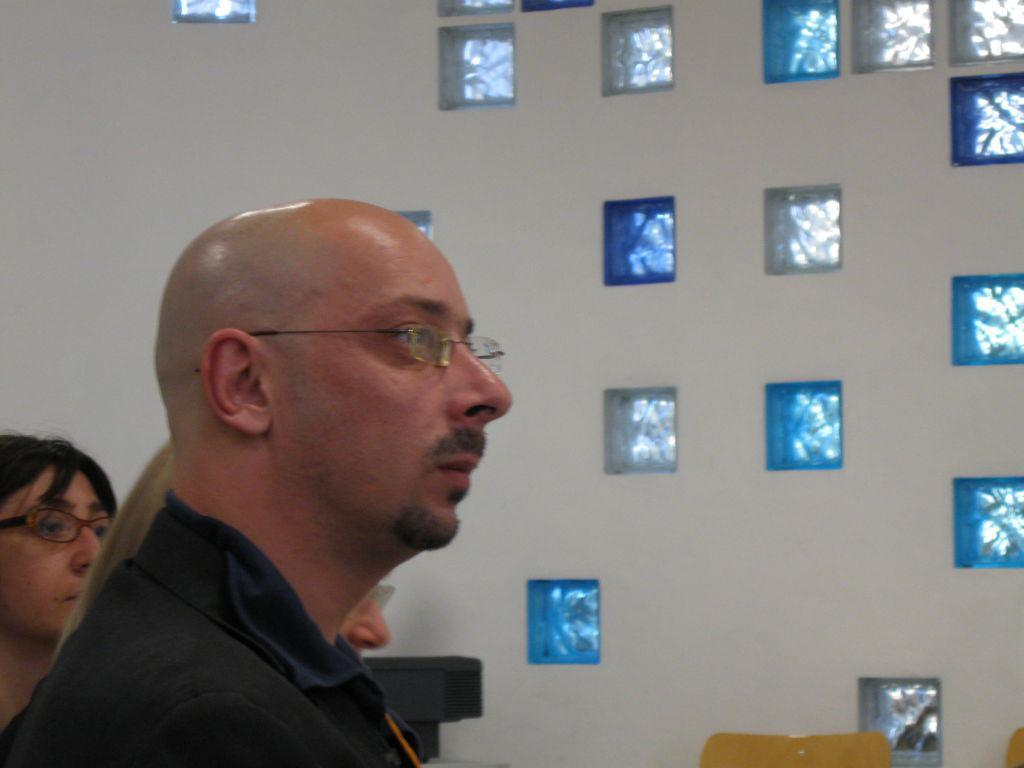What type of view is shown in the image? The image is an inside view. Can you describe the people on the left side of the image? There is a man and two women on the left side of the image, with the women facing the right side. What is visible in the background of the image? There is a wall in the background of the image. What piece of furniture is located at the bottom of the image? There is a chair at the bottom of the image. What type of goose can be seen flying around the room in the image? There is no goose present in the image; it is an inside view with no visible animals. Can you describe the curve of the wall in the image? The provided facts do not mention any curves in the wall, only that there is a wall in the background. 